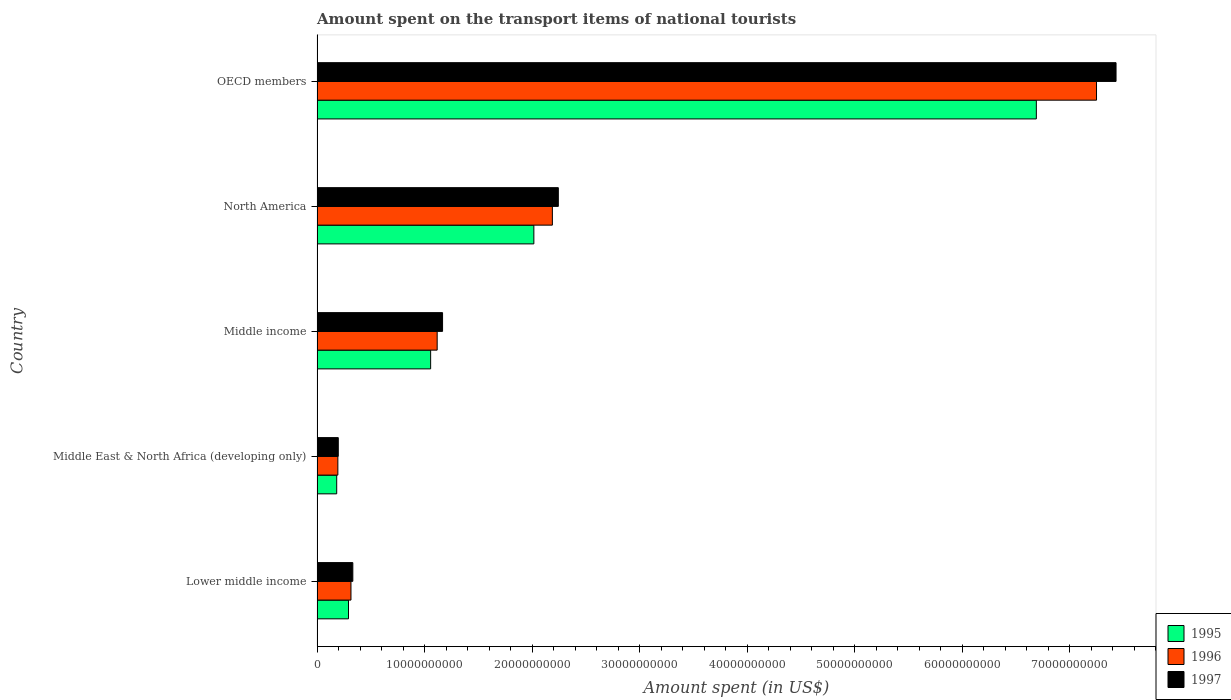How many different coloured bars are there?
Make the answer very short. 3. Are the number of bars per tick equal to the number of legend labels?
Provide a succinct answer. Yes. How many bars are there on the 3rd tick from the top?
Ensure brevity in your answer.  3. What is the label of the 3rd group of bars from the top?
Offer a very short reply. Middle income. In how many cases, is the number of bars for a given country not equal to the number of legend labels?
Ensure brevity in your answer.  0. What is the amount spent on the transport items of national tourists in 1996 in OECD members?
Provide a short and direct response. 7.25e+1. Across all countries, what is the maximum amount spent on the transport items of national tourists in 1997?
Your response must be concise. 7.43e+1. Across all countries, what is the minimum amount spent on the transport items of national tourists in 1997?
Offer a terse response. 1.97e+09. In which country was the amount spent on the transport items of national tourists in 1995 maximum?
Provide a succinct answer. OECD members. In which country was the amount spent on the transport items of national tourists in 1997 minimum?
Your response must be concise. Middle East & North Africa (developing only). What is the total amount spent on the transport items of national tourists in 1995 in the graph?
Your answer should be compact. 1.02e+11. What is the difference between the amount spent on the transport items of national tourists in 1997 in Lower middle income and that in North America?
Your answer should be compact. -1.91e+1. What is the difference between the amount spent on the transport items of national tourists in 1995 in Middle income and the amount spent on the transport items of national tourists in 1997 in OECD members?
Make the answer very short. -6.38e+1. What is the average amount spent on the transport items of national tourists in 1997 per country?
Give a very brief answer. 2.27e+1. What is the difference between the amount spent on the transport items of national tourists in 1996 and amount spent on the transport items of national tourists in 1997 in Middle income?
Give a very brief answer. -5.01e+08. In how many countries, is the amount spent on the transport items of national tourists in 1996 greater than 46000000000 US$?
Your response must be concise. 1. What is the ratio of the amount spent on the transport items of national tourists in 1997 in Middle income to that in North America?
Provide a short and direct response. 0.52. Is the difference between the amount spent on the transport items of national tourists in 1996 in Middle East & North Africa (developing only) and Middle income greater than the difference between the amount spent on the transport items of national tourists in 1997 in Middle East & North Africa (developing only) and Middle income?
Your response must be concise. Yes. What is the difference between the highest and the second highest amount spent on the transport items of national tourists in 1995?
Your answer should be compact. 4.67e+1. What is the difference between the highest and the lowest amount spent on the transport items of national tourists in 1996?
Offer a very short reply. 7.06e+1. In how many countries, is the amount spent on the transport items of national tourists in 1995 greater than the average amount spent on the transport items of national tourists in 1995 taken over all countries?
Your answer should be compact. 1. What does the 2nd bar from the top in North America represents?
Make the answer very short. 1996. What does the 3rd bar from the bottom in OECD members represents?
Your answer should be compact. 1997. Is it the case that in every country, the sum of the amount spent on the transport items of national tourists in 1996 and amount spent on the transport items of national tourists in 1995 is greater than the amount spent on the transport items of national tourists in 1997?
Your answer should be very brief. Yes. What is the difference between two consecutive major ticks on the X-axis?
Your response must be concise. 1.00e+1. Are the values on the major ticks of X-axis written in scientific E-notation?
Make the answer very short. No. How many legend labels are there?
Your answer should be compact. 3. How are the legend labels stacked?
Offer a very short reply. Vertical. What is the title of the graph?
Give a very brief answer. Amount spent on the transport items of national tourists. What is the label or title of the X-axis?
Keep it short and to the point. Amount spent (in US$). What is the Amount spent (in US$) in 1995 in Lower middle income?
Your answer should be very brief. 2.92e+09. What is the Amount spent (in US$) in 1996 in Lower middle income?
Give a very brief answer. 3.16e+09. What is the Amount spent (in US$) of 1997 in Lower middle income?
Your response must be concise. 3.33e+09. What is the Amount spent (in US$) in 1995 in Middle East & North Africa (developing only)?
Keep it short and to the point. 1.83e+09. What is the Amount spent (in US$) in 1996 in Middle East & North Africa (developing only)?
Offer a very short reply. 1.94e+09. What is the Amount spent (in US$) of 1997 in Middle East & North Africa (developing only)?
Your response must be concise. 1.97e+09. What is the Amount spent (in US$) in 1995 in Middle income?
Offer a very short reply. 1.06e+1. What is the Amount spent (in US$) in 1996 in Middle income?
Keep it short and to the point. 1.12e+1. What is the Amount spent (in US$) in 1997 in Middle income?
Ensure brevity in your answer.  1.17e+1. What is the Amount spent (in US$) in 1995 in North America?
Keep it short and to the point. 2.02e+1. What is the Amount spent (in US$) in 1996 in North America?
Offer a very short reply. 2.19e+1. What is the Amount spent (in US$) in 1997 in North America?
Your answer should be compact. 2.24e+1. What is the Amount spent (in US$) in 1995 in OECD members?
Ensure brevity in your answer.  6.69e+1. What is the Amount spent (in US$) of 1996 in OECD members?
Provide a short and direct response. 7.25e+1. What is the Amount spent (in US$) of 1997 in OECD members?
Provide a short and direct response. 7.43e+1. Across all countries, what is the maximum Amount spent (in US$) of 1995?
Your answer should be very brief. 6.69e+1. Across all countries, what is the maximum Amount spent (in US$) in 1996?
Ensure brevity in your answer.  7.25e+1. Across all countries, what is the maximum Amount spent (in US$) of 1997?
Give a very brief answer. 7.43e+1. Across all countries, what is the minimum Amount spent (in US$) in 1995?
Give a very brief answer. 1.83e+09. Across all countries, what is the minimum Amount spent (in US$) in 1996?
Offer a terse response. 1.94e+09. Across all countries, what is the minimum Amount spent (in US$) of 1997?
Offer a very short reply. 1.97e+09. What is the total Amount spent (in US$) in 1995 in the graph?
Provide a short and direct response. 1.02e+11. What is the total Amount spent (in US$) of 1996 in the graph?
Keep it short and to the point. 1.11e+11. What is the total Amount spent (in US$) of 1997 in the graph?
Provide a succinct answer. 1.14e+11. What is the difference between the Amount spent (in US$) of 1995 in Lower middle income and that in Middle East & North Africa (developing only)?
Ensure brevity in your answer.  1.10e+09. What is the difference between the Amount spent (in US$) of 1996 in Lower middle income and that in Middle East & North Africa (developing only)?
Ensure brevity in your answer.  1.22e+09. What is the difference between the Amount spent (in US$) in 1997 in Lower middle income and that in Middle East & North Africa (developing only)?
Your answer should be compact. 1.35e+09. What is the difference between the Amount spent (in US$) of 1995 in Lower middle income and that in Middle income?
Offer a very short reply. -7.64e+09. What is the difference between the Amount spent (in US$) in 1996 in Lower middle income and that in Middle income?
Your answer should be very brief. -8.02e+09. What is the difference between the Amount spent (in US$) of 1997 in Lower middle income and that in Middle income?
Offer a very short reply. -8.35e+09. What is the difference between the Amount spent (in US$) in 1995 in Lower middle income and that in North America?
Provide a short and direct response. -1.72e+1. What is the difference between the Amount spent (in US$) in 1996 in Lower middle income and that in North America?
Ensure brevity in your answer.  -1.87e+1. What is the difference between the Amount spent (in US$) of 1997 in Lower middle income and that in North America?
Ensure brevity in your answer.  -1.91e+1. What is the difference between the Amount spent (in US$) in 1995 in Lower middle income and that in OECD members?
Offer a terse response. -6.40e+1. What is the difference between the Amount spent (in US$) in 1996 in Lower middle income and that in OECD members?
Give a very brief answer. -6.94e+1. What is the difference between the Amount spent (in US$) of 1997 in Lower middle income and that in OECD members?
Offer a terse response. -7.10e+1. What is the difference between the Amount spent (in US$) of 1995 in Middle East & North Africa (developing only) and that in Middle income?
Your answer should be compact. -8.74e+09. What is the difference between the Amount spent (in US$) in 1996 in Middle East & North Africa (developing only) and that in Middle income?
Provide a short and direct response. -9.24e+09. What is the difference between the Amount spent (in US$) of 1997 in Middle East & North Africa (developing only) and that in Middle income?
Keep it short and to the point. -9.70e+09. What is the difference between the Amount spent (in US$) in 1995 in Middle East & North Africa (developing only) and that in North America?
Give a very brief answer. -1.83e+1. What is the difference between the Amount spent (in US$) in 1996 in Middle East & North Africa (developing only) and that in North America?
Offer a very short reply. -2.00e+1. What is the difference between the Amount spent (in US$) of 1997 in Middle East & North Africa (developing only) and that in North America?
Keep it short and to the point. -2.05e+1. What is the difference between the Amount spent (in US$) of 1995 in Middle East & North Africa (developing only) and that in OECD members?
Keep it short and to the point. -6.51e+1. What is the difference between the Amount spent (in US$) in 1996 in Middle East & North Africa (developing only) and that in OECD members?
Your response must be concise. -7.06e+1. What is the difference between the Amount spent (in US$) of 1997 in Middle East & North Africa (developing only) and that in OECD members?
Your answer should be very brief. -7.24e+1. What is the difference between the Amount spent (in US$) of 1995 in Middle income and that in North America?
Make the answer very short. -9.60e+09. What is the difference between the Amount spent (in US$) in 1996 in Middle income and that in North America?
Provide a short and direct response. -1.07e+1. What is the difference between the Amount spent (in US$) of 1997 in Middle income and that in North America?
Make the answer very short. -1.08e+1. What is the difference between the Amount spent (in US$) in 1995 in Middle income and that in OECD members?
Your answer should be very brief. -5.63e+1. What is the difference between the Amount spent (in US$) in 1996 in Middle income and that in OECD members?
Ensure brevity in your answer.  -6.13e+1. What is the difference between the Amount spent (in US$) of 1997 in Middle income and that in OECD members?
Ensure brevity in your answer.  -6.27e+1. What is the difference between the Amount spent (in US$) in 1995 in North America and that in OECD members?
Your response must be concise. -4.67e+1. What is the difference between the Amount spent (in US$) of 1996 in North America and that in OECD members?
Provide a short and direct response. -5.06e+1. What is the difference between the Amount spent (in US$) in 1997 in North America and that in OECD members?
Offer a terse response. -5.19e+1. What is the difference between the Amount spent (in US$) in 1995 in Lower middle income and the Amount spent (in US$) in 1996 in Middle East & North Africa (developing only)?
Your answer should be compact. 9.90e+08. What is the difference between the Amount spent (in US$) of 1995 in Lower middle income and the Amount spent (in US$) of 1997 in Middle East & North Africa (developing only)?
Offer a terse response. 9.50e+08. What is the difference between the Amount spent (in US$) of 1996 in Lower middle income and the Amount spent (in US$) of 1997 in Middle East & North Africa (developing only)?
Keep it short and to the point. 1.18e+09. What is the difference between the Amount spent (in US$) in 1995 in Lower middle income and the Amount spent (in US$) in 1996 in Middle income?
Provide a succinct answer. -8.25e+09. What is the difference between the Amount spent (in US$) in 1995 in Lower middle income and the Amount spent (in US$) in 1997 in Middle income?
Your answer should be very brief. -8.75e+09. What is the difference between the Amount spent (in US$) in 1996 in Lower middle income and the Amount spent (in US$) in 1997 in Middle income?
Your response must be concise. -8.52e+09. What is the difference between the Amount spent (in US$) in 1995 in Lower middle income and the Amount spent (in US$) in 1996 in North America?
Give a very brief answer. -1.90e+1. What is the difference between the Amount spent (in US$) in 1995 in Lower middle income and the Amount spent (in US$) in 1997 in North America?
Ensure brevity in your answer.  -1.95e+1. What is the difference between the Amount spent (in US$) of 1996 in Lower middle income and the Amount spent (in US$) of 1997 in North America?
Your response must be concise. -1.93e+1. What is the difference between the Amount spent (in US$) in 1995 in Lower middle income and the Amount spent (in US$) in 1996 in OECD members?
Your answer should be compact. -6.96e+1. What is the difference between the Amount spent (in US$) in 1995 in Lower middle income and the Amount spent (in US$) in 1997 in OECD members?
Your answer should be very brief. -7.14e+1. What is the difference between the Amount spent (in US$) in 1996 in Lower middle income and the Amount spent (in US$) in 1997 in OECD members?
Your response must be concise. -7.12e+1. What is the difference between the Amount spent (in US$) of 1995 in Middle East & North Africa (developing only) and the Amount spent (in US$) of 1996 in Middle income?
Your answer should be compact. -9.35e+09. What is the difference between the Amount spent (in US$) in 1995 in Middle East & North Africa (developing only) and the Amount spent (in US$) in 1997 in Middle income?
Provide a succinct answer. -9.85e+09. What is the difference between the Amount spent (in US$) of 1996 in Middle East & North Africa (developing only) and the Amount spent (in US$) of 1997 in Middle income?
Offer a very short reply. -9.74e+09. What is the difference between the Amount spent (in US$) of 1995 in Middle East & North Africa (developing only) and the Amount spent (in US$) of 1996 in North America?
Your answer should be very brief. -2.01e+1. What is the difference between the Amount spent (in US$) in 1995 in Middle East & North Africa (developing only) and the Amount spent (in US$) in 1997 in North America?
Your answer should be very brief. -2.06e+1. What is the difference between the Amount spent (in US$) of 1996 in Middle East & North Africa (developing only) and the Amount spent (in US$) of 1997 in North America?
Your answer should be compact. -2.05e+1. What is the difference between the Amount spent (in US$) in 1995 in Middle East & North Africa (developing only) and the Amount spent (in US$) in 1996 in OECD members?
Give a very brief answer. -7.07e+1. What is the difference between the Amount spent (in US$) of 1995 in Middle East & North Africa (developing only) and the Amount spent (in US$) of 1997 in OECD members?
Give a very brief answer. -7.25e+1. What is the difference between the Amount spent (in US$) of 1996 in Middle East & North Africa (developing only) and the Amount spent (in US$) of 1997 in OECD members?
Make the answer very short. -7.24e+1. What is the difference between the Amount spent (in US$) of 1995 in Middle income and the Amount spent (in US$) of 1996 in North America?
Offer a very short reply. -1.13e+1. What is the difference between the Amount spent (in US$) of 1995 in Middle income and the Amount spent (in US$) of 1997 in North America?
Keep it short and to the point. -1.19e+1. What is the difference between the Amount spent (in US$) in 1996 in Middle income and the Amount spent (in US$) in 1997 in North America?
Your response must be concise. -1.13e+1. What is the difference between the Amount spent (in US$) in 1995 in Middle income and the Amount spent (in US$) in 1996 in OECD members?
Your answer should be compact. -6.19e+1. What is the difference between the Amount spent (in US$) in 1995 in Middle income and the Amount spent (in US$) in 1997 in OECD members?
Keep it short and to the point. -6.38e+1. What is the difference between the Amount spent (in US$) of 1996 in Middle income and the Amount spent (in US$) of 1997 in OECD members?
Your response must be concise. -6.32e+1. What is the difference between the Amount spent (in US$) of 1995 in North America and the Amount spent (in US$) of 1996 in OECD members?
Keep it short and to the point. -5.23e+1. What is the difference between the Amount spent (in US$) of 1995 in North America and the Amount spent (in US$) of 1997 in OECD members?
Make the answer very short. -5.42e+1. What is the difference between the Amount spent (in US$) of 1996 in North America and the Amount spent (in US$) of 1997 in OECD members?
Your answer should be compact. -5.24e+1. What is the average Amount spent (in US$) of 1995 per country?
Your answer should be very brief. 2.05e+1. What is the average Amount spent (in US$) of 1996 per country?
Make the answer very short. 2.21e+1. What is the average Amount spent (in US$) of 1997 per country?
Your response must be concise. 2.27e+1. What is the difference between the Amount spent (in US$) of 1995 and Amount spent (in US$) of 1996 in Lower middle income?
Give a very brief answer. -2.31e+08. What is the difference between the Amount spent (in US$) in 1995 and Amount spent (in US$) in 1997 in Lower middle income?
Your response must be concise. -4.03e+08. What is the difference between the Amount spent (in US$) of 1996 and Amount spent (in US$) of 1997 in Lower middle income?
Provide a short and direct response. -1.73e+08. What is the difference between the Amount spent (in US$) of 1995 and Amount spent (in US$) of 1996 in Middle East & North Africa (developing only)?
Provide a short and direct response. -1.08e+08. What is the difference between the Amount spent (in US$) in 1995 and Amount spent (in US$) in 1997 in Middle East & North Africa (developing only)?
Keep it short and to the point. -1.47e+08. What is the difference between the Amount spent (in US$) in 1996 and Amount spent (in US$) in 1997 in Middle East & North Africa (developing only)?
Make the answer very short. -3.92e+07. What is the difference between the Amount spent (in US$) of 1995 and Amount spent (in US$) of 1996 in Middle income?
Offer a very short reply. -6.08e+08. What is the difference between the Amount spent (in US$) of 1995 and Amount spent (in US$) of 1997 in Middle income?
Provide a succinct answer. -1.11e+09. What is the difference between the Amount spent (in US$) of 1996 and Amount spent (in US$) of 1997 in Middle income?
Provide a succinct answer. -5.01e+08. What is the difference between the Amount spent (in US$) in 1995 and Amount spent (in US$) in 1996 in North America?
Give a very brief answer. -1.72e+09. What is the difference between the Amount spent (in US$) of 1995 and Amount spent (in US$) of 1997 in North America?
Your answer should be compact. -2.28e+09. What is the difference between the Amount spent (in US$) of 1996 and Amount spent (in US$) of 1997 in North America?
Provide a succinct answer. -5.53e+08. What is the difference between the Amount spent (in US$) in 1995 and Amount spent (in US$) in 1996 in OECD members?
Give a very brief answer. -5.60e+09. What is the difference between the Amount spent (in US$) of 1995 and Amount spent (in US$) of 1997 in OECD members?
Offer a terse response. -7.41e+09. What is the difference between the Amount spent (in US$) in 1996 and Amount spent (in US$) in 1997 in OECD members?
Offer a terse response. -1.82e+09. What is the ratio of the Amount spent (in US$) in 1995 in Lower middle income to that in Middle East & North Africa (developing only)?
Offer a very short reply. 1.6. What is the ratio of the Amount spent (in US$) of 1996 in Lower middle income to that in Middle East & North Africa (developing only)?
Offer a terse response. 1.63. What is the ratio of the Amount spent (in US$) in 1997 in Lower middle income to that in Middle East & North Africa (developing only)?
Your answer should be compact. 1.69. What is the ratio of the Amount spent (in US$) of 1995 in Lower middle income to that in Middle income?
Offer a very short reply. 0.28. What is the ratio of the Amount spent (in US$) in 1996 in Lower middle income to that in Middle income?
Provide a succinct answer. 0.28. What is the ratio of the Amount spent (in US$) of 1997 in Lower middle income to that in Middle income?
Your response must be concise. 0.29. What is the ratio of the Amount spent (in US$) of 1995 in Lower middle income to that in North America?
Ensure brevity in your answer.  0.14. What is the ratio of the Amount spent (in US$) in 1996 in Lower middle income to that in North America?
Provide a short and direct response. 0.14. What is the ratio of the Amount spent (in US$) of 1997 in Lower middle income to that in North America?
Offer a very short reply. 0.15. What is the ratio of the Amount spent (in US$) in 1995 in Lower middle income to that in OECD members?
Provide a short and direct response. 0.04. What is the ratio of the Amount spent (in US$) of 1996 in Lower middle income to that in OECD members?
Offer a very short reply. 0.04. What is the ratio of the Amount spent (in US$) in 1997 in Lower middle income to that in OECD members?
Offer a terse response. 0.04. What is the ratio of the Amount spent (in US$) in 1995 in Middle East & North Africa (developing only) to that in Middle income?
Keep it short and to the point. 0.17. What is the ratio of the Amount spent (in US$) in 1996 in Middle East & North Africa (developing only) to that in Middle income?
Your answer should be very brief. 0.17. What is the ratio of the Amount spent (in US$) in 1997 in Middle East & North Africa (developing only) to that in Middle income?
Ensure brevity in your answer.  0.17. What is the ratio of the Amount spent (in US$) of 1995 in Middle East & North Africa (developing only) to that in North America?
Provide a short and direct response. 0.09. What is the ratio of the Amount spent (in US$) in 1996 in Middle East & North Africa (developing only) to that in North America?
Your response must be concise. 0.09. What is the ratio of the Amount spent (in US$) in 1997 in Middle East & North Africa (developing only) to that in North America?
Offer a terse response. 0.09. What is the ratio of the Amount spent (in US$) in 1995 in Middle East & North Africa (developing only) to that in OECD members?
Offer a terse response. 0.03. What is the ratio of the Amount spent (in US$) in 1996 in Middle East & North Africa (developing only) to that in OECD members?
Your response must be concise. 0.03. What is the ratio of the Amount spent (in US$) in 1997 in Middle East & North Africa (developing only) to that in OECD members?
Give a very brief answer. 0.03. What is the ratio of the Amount spent (in US$) of 1995 in Middle income to that in North America?
Offer a very short reply. 0.52. What is the ratio of the Amount spent (in US$) in 1996 in Middle income to that in North America?
Your response must be concise. 0.51. What is the ratio of the Amount spent (in US$) in 1997 in Middle income to that in North America?
Your answer should be compact. 0.52. What is the ratio of the Amount spent (in US$) of 1995 in Middle income to that in OECD members?
Offer a very short reply. 0.16. What is the ratio of the Amount spent (in US$) of 1996 in Middle income to that in OECD members?
Offer a very short reply. 0.15. What is the ratio of the Amount spent (in US$) of 1997 in Middle income to that in OECD members?
Make the answer very short. 0.16. What is the ratio of the Amount spent (in US$) of 1995 in North America to that in OECD members?
Provide a succinct answer. 0.3. What is the ratio of the Amount spent (in US$) of 1996 in North America to that in OECD members?
Your answer should be compact. 0.3. What is the ratio of the Amount spent (in US$) of 1997 in North America to that in OECD members?
Keep it short and to the point. 0.3. What is the difference between the highest and the second highest Amount spent (in US$) of 1995?
Your answer should be very brief. 4.67e+1. What is the difference between the highest and the second highest Amount spent (in US$) of 1996?
Provide a short and direct response. 5.06e+1. What is the difference between the highest and the second highest Amount spent (in US$) in 1997?
Your answer should be very brief. 5.19e+1. What is the difference between the highest and the lowest Amount spent (in US$) in 1995?
Offer a very short reply. 6.51e+1. What is the difference between the highest and the lowest Amount spent (in US$) in 1996?
Offer a terse response. 7.06e+1. What is the difference between the highest and the lowest Amount spent (in US$) in 1997?
Your answer should be very brief. 7.24e+1. 